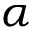<formula> <loc_0><loc_0><loc_500><loc_500>\alpha</formula> 